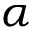<formula> <loc_0><loc_0><loc_500><loc_500>\alpha</formula> 